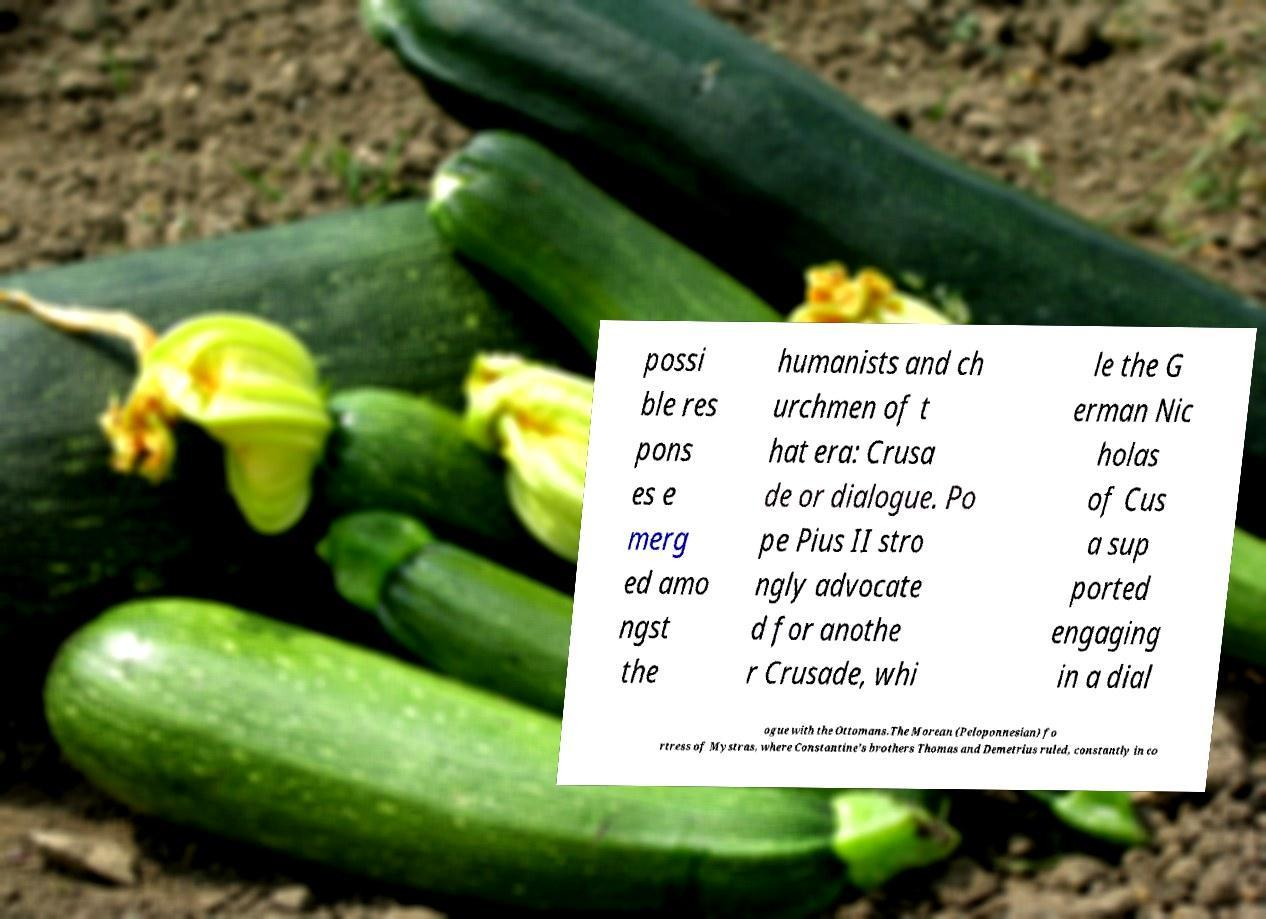There's text embedded in this image that I need extracted. Can you transcribe it verbatim? possi ble res pons es e merg ed amo ngst the humanists and ch urchmen of t hat era: Crusa de or dialogue. Po pe Pius II stro ngly advocate d for anothe r Crusade, whi le the G erman Nic holas of Cus a sup ported engaging in a dial ogue with the Ottomans.The Morean (Peloponnesian) fo rtress of Mystras, where Constantine's brothers Thomas and Demetrius ruled, constantly in co 